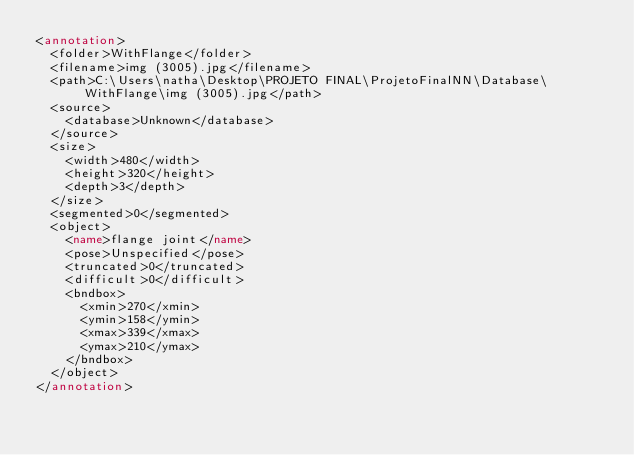<code> <loc_0><loc_0><loc_500><loc_500><_XML_><annotation>
	<folder>WithFlange</folder>
	<filename>img (3005).jpg</filename>
	<path>C:\Users\natha\Desktop\PROJETO FINAL\ProjetoFinalNN\Database\WithFlange\img (3005).jpg</path>
	<source>
		<database>Unknown</database>
	</source>
	<size>
		<width>480</width>
		<height>320</height>
		<depth>3</depth>
	</size>
	<segmented>0</segmented>
	<object>
		<name>flange joint</name>
		<pose>Unspecified</pose>
		<truncated>0</truncated>
		<difficult>0</difficult>
		<bndbox>
			<xmin>270</xmin>
			<ymin>158</ymin>
			<xmax>339</xmax>
			<ymax>210</ymax>
		</bndbox>
	</object>
</annotation>
</code> 